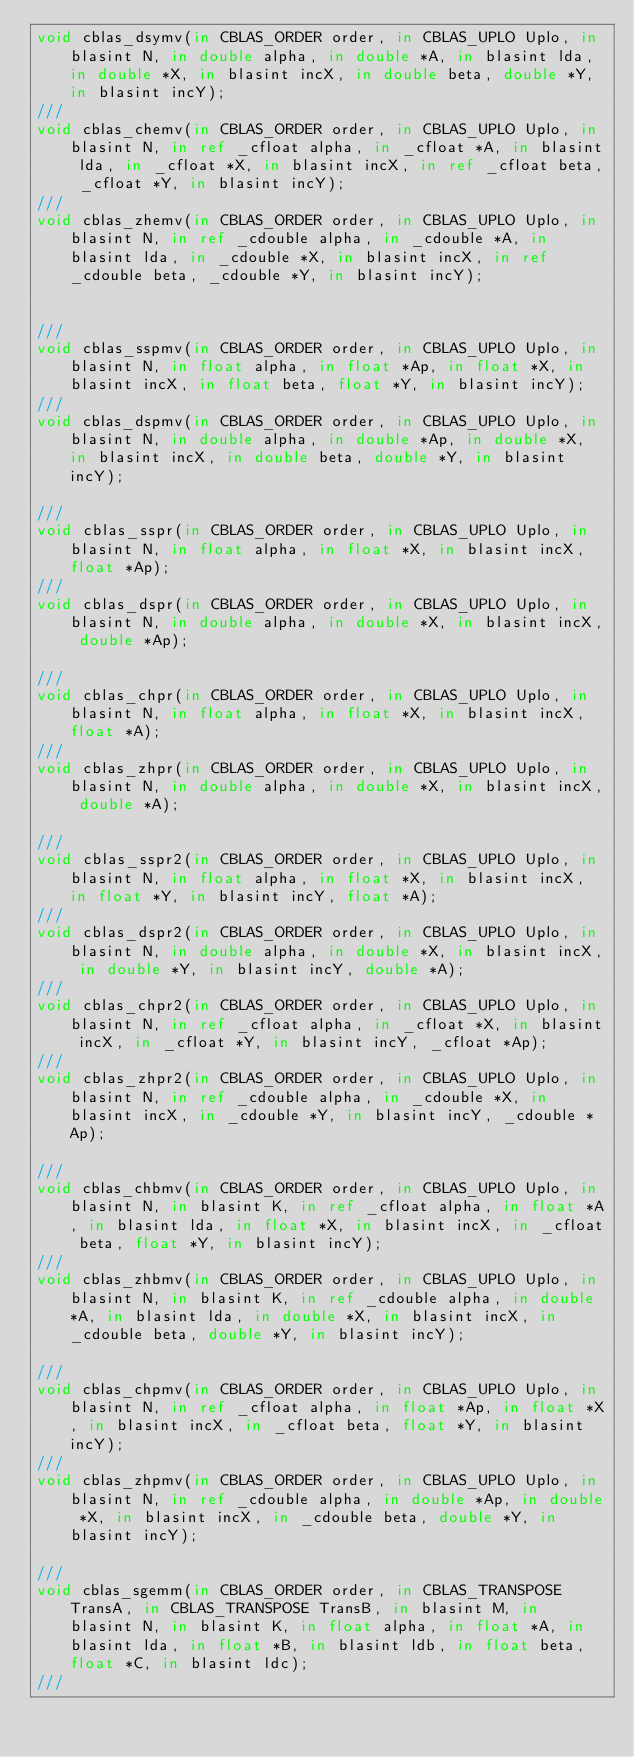<code> <loc_0><loc_0><loc_500><loc_500><_D_>void cblas_dsymv(in CBLAS_ORDER order, in CBLAS_UPLO Uplo, in blasint N, in double alpha, in double *A, in blasint lda, in double *X, in blasint incX, in double beta, double *Y, in blasint incY);
///
void cblas_chemv(in CBLAS_ORDER order, in CBLAS_UPLO Uplo, in blasint N, in ref _cfloat alpha, in _cfloat *A, in blasint lda, in _cfloat *X, in blasint incX, in ref _cfloat beta, _cfloat *Y, in blasint incY);
///
void cblas_zhemv(in CBLAS_ORDER order, in CBLAS_UPLO Uplo, in blasint N, in ref _cdouble alpha, in _cdouble *A, in blasint lda, in _cdouble *X, in blasint incX, in ref _cdouble beta, _cdouble *Y, in blasint incY);


///
void cblas_sspmv(in CBLAS_ORDER order, in CBLAS_UPLO Uplo, in blasint N, in float alpha, in float *Ap, in float *X, in blasint incX, in float beta, float *Y, in blasint incY);
///
void cblas_dspmv(in CBLAS_ORDER order, in CBLAS_UPLO Uplo, in blasint N, in double alpha, in double *Ap, in double *X, in blasint incX, in double beta, double *Y, in blasint incY);

///
void cblas_sspr(in CBLAS_ORDER order, in CBLAS_UPLO Uplo, in blasint N, in float alpha, in float *X, in blasint incX, float *Ap);
///
void cblas_dspr(in CBLAS_ORDER order, in CBLAS_UPLO Uplo, in blasint N, in double alpha, in double *X, in blasint incX, double *Ap);

///
void cblas_chpr(in CBLAS_ORDER order, in CBLAS_UPLO Uplo, in blasint N, in float alpha, in float *X, in blasint incX, float *A);
///
void cblas_zhpr(in CBLAS_ORDER order, in CBLAS_UPLO Uplo, in blasint N, in double alpha, in double *X, in blasint incX, double *A);

///
void cblas_sspr2(in CBLAS_ORDER order, in CBLAS_UPLO Uplo, in blasint N, in float alpha, in float *X, in blasint incX, in float *Y, in blasint incY, float *A);
///
void cblas_dspr2(in CBLAS_ORDER order, in CBLAS_UPLO Uplo, in blasint N, in double alpha, in double *X, in blasint incX, in double *Y, in blasint incY, double *A);
///
void cblas_chpr2(in CBLAS_ORDER order, in CBLAS_UPLO Uplo, in blasint N, in ref _cfloat alpha, in _cfloat *X, in blasint incX, in _cfloat *Y, in blasint incY, _cfloat *Ap);
///
void cblas_zhpr2(in CBLAS_ORDER order, in CBLAS_UPLO Uplo, in blasint N, in ref _cdouble alpha, in _cdouble *X, in blasint incX, in _cdouble *Y, in blasint incY, _cdouble *Ap);

///
void cblas_chbmv(in CBLAS_ORDER order, in CBLAS_UPLO Uplo, in blasint N, in blasint K, in ref _cfloat alpha, in float *A, in blasint lda, in float *X, in blasint incX, in _cfloat beta, float *Y, in blasint incY);
///
void cblas_zhbmv(in CBLAS_ORDER order, in CBLAS_UPLO Uplo, in blasint N, in blasint K, in ref _cdouble alpha, in double *A, in blasint lda, in double *X, in blasint incX, in _cdouble beta, double *Y, in blasint incY);

///
void cblas_chpmv(in CBLAS_ORDER order, in CBLAS_UPLO Uplo, in blasint N, in ref _cfloat alpha, in float *Ap, in float *X, in blasint incX, in _cfloat beta, float *Y, in blasint incY);
///
void cblas_zhpmv(in CBLAS_ORDER order, in CBLAS_UPLO Uplo, in blasint N, in ref _cdouble alpha, in double *Ap, in double *X, in blasint incX, in _cdouble beta, double *Y, in blasint incY);

///
void cblas_sgemm(in CBLAS_ORDER order, in CBLAS_TRANSPOSE TransA, in CBLAS_TRANSPOSE TransB, in blasint M, in blasint N, in blasint K, in float alpha, in float *A, in blasint lda, in float *B, in blasint ldb, in float beta, float *C, in blasint ldc);
///</code> 